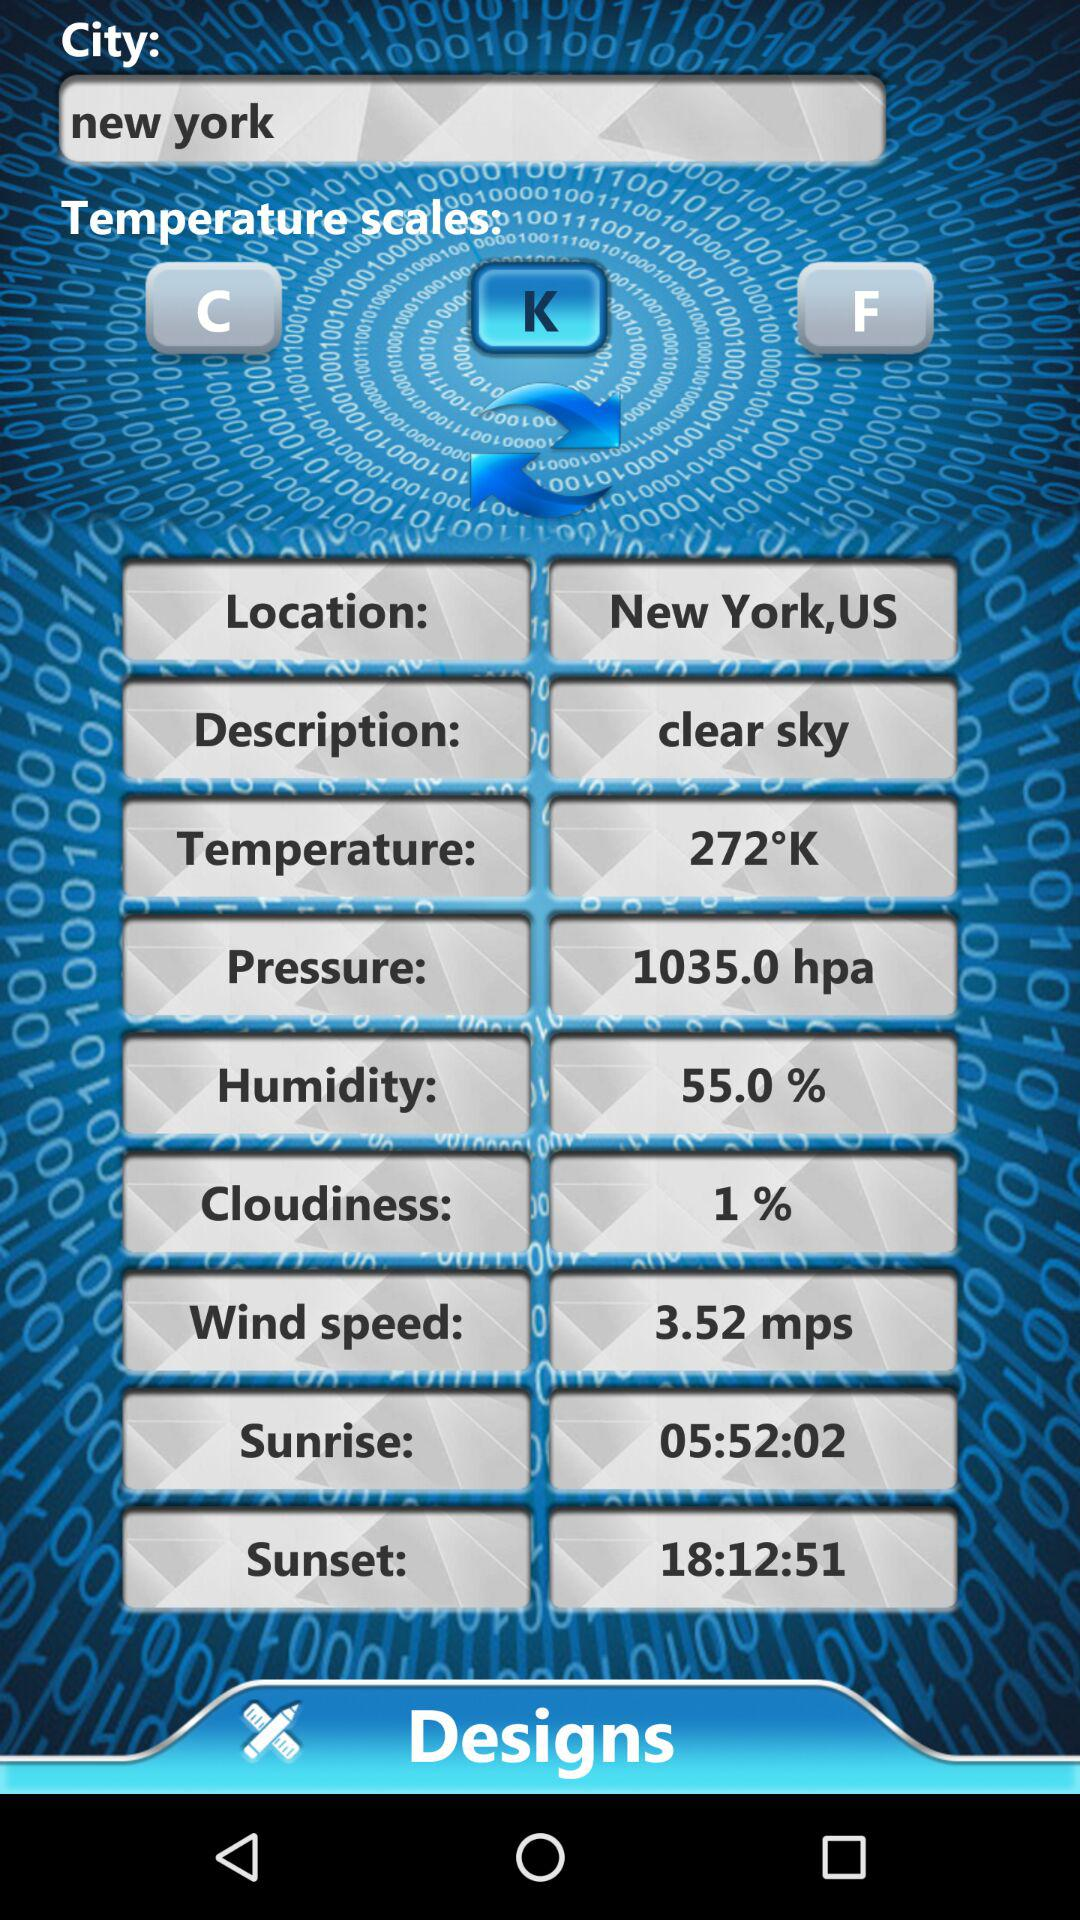What is the time of sunrise? The time of sunrise is 05:52:02. 